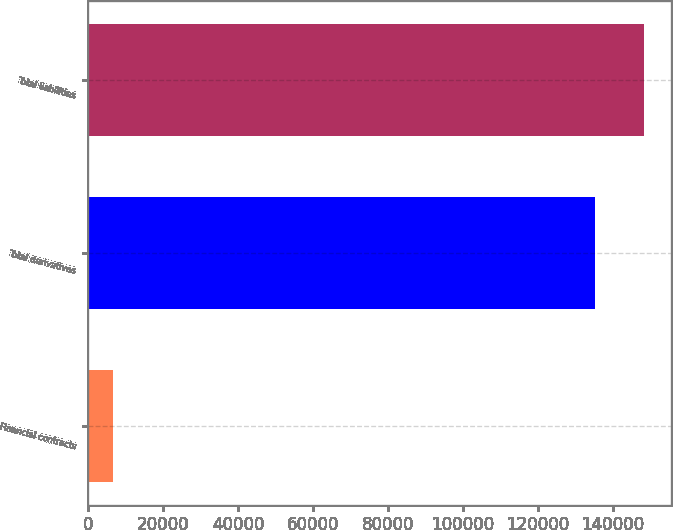<chart> <loc_0><loc_0><loc_500><loc_500><bar_chart><fcel>Financial contracts<fcel>Total derivatives<fcel>Total liabilities<nl><fcel>6498<fcel>135425<fcel>148318<nl></chart> 